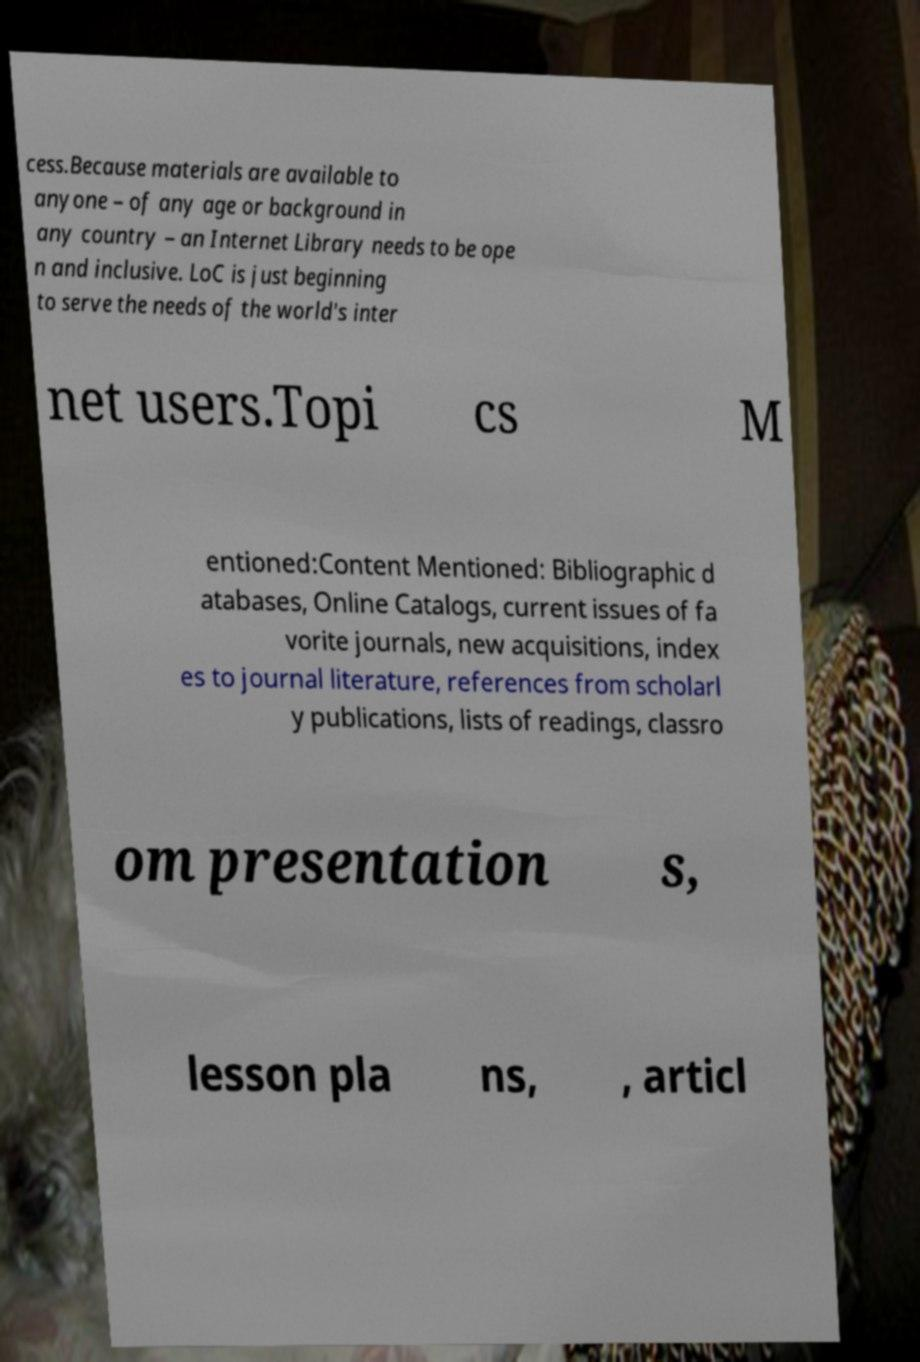What messages or text are displayed in this image? I need them in a readable, typed format. cess.Because materials are available to anyone – of any age or background in any country – an Internet Library needs to be ope n and inclusive. LoC is just beginning to serve the needs of the world's inter net users.Topi cs M entioned:Content Mentioned: Bibliographic d atabases, Online Catalogs, current issues of fa vorite journals, new acquisitions, index es to journal literature, references from scholarl y publications, lists of readings, classro om presentation s, lesson pla ns, , articl 